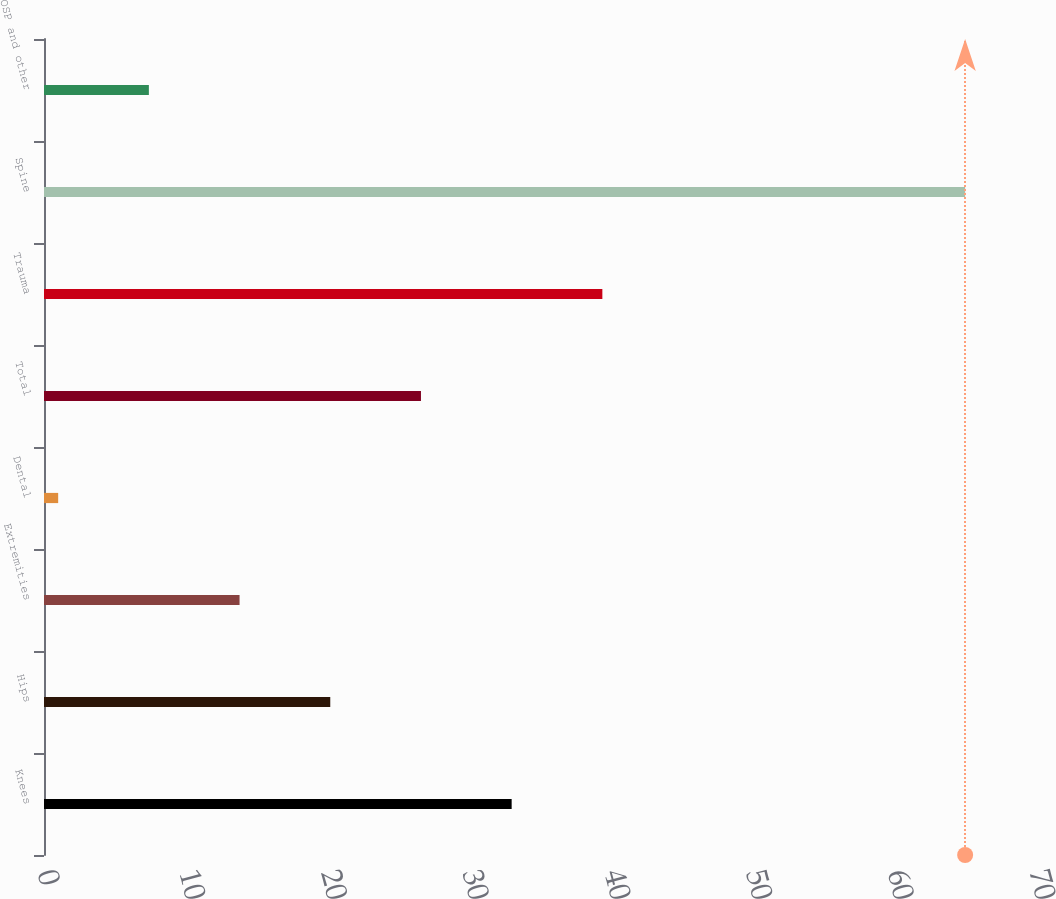Convert chart. <chart><loc_0><loc_0><loc_500><loc_500><bar_chart><fcel>Knees<fcel>Hips<fcel>Extremities<fcel>Dental<fcel>Total<fcel>Trauma<fcel>Spine<fcel>OSP and other<nl><fcel>33<fcel>20.2<fcel>13.8<fcel>1<fcel>26.6<fcel>39.4<fcel>65<fcel>7.4<nl></chart> 